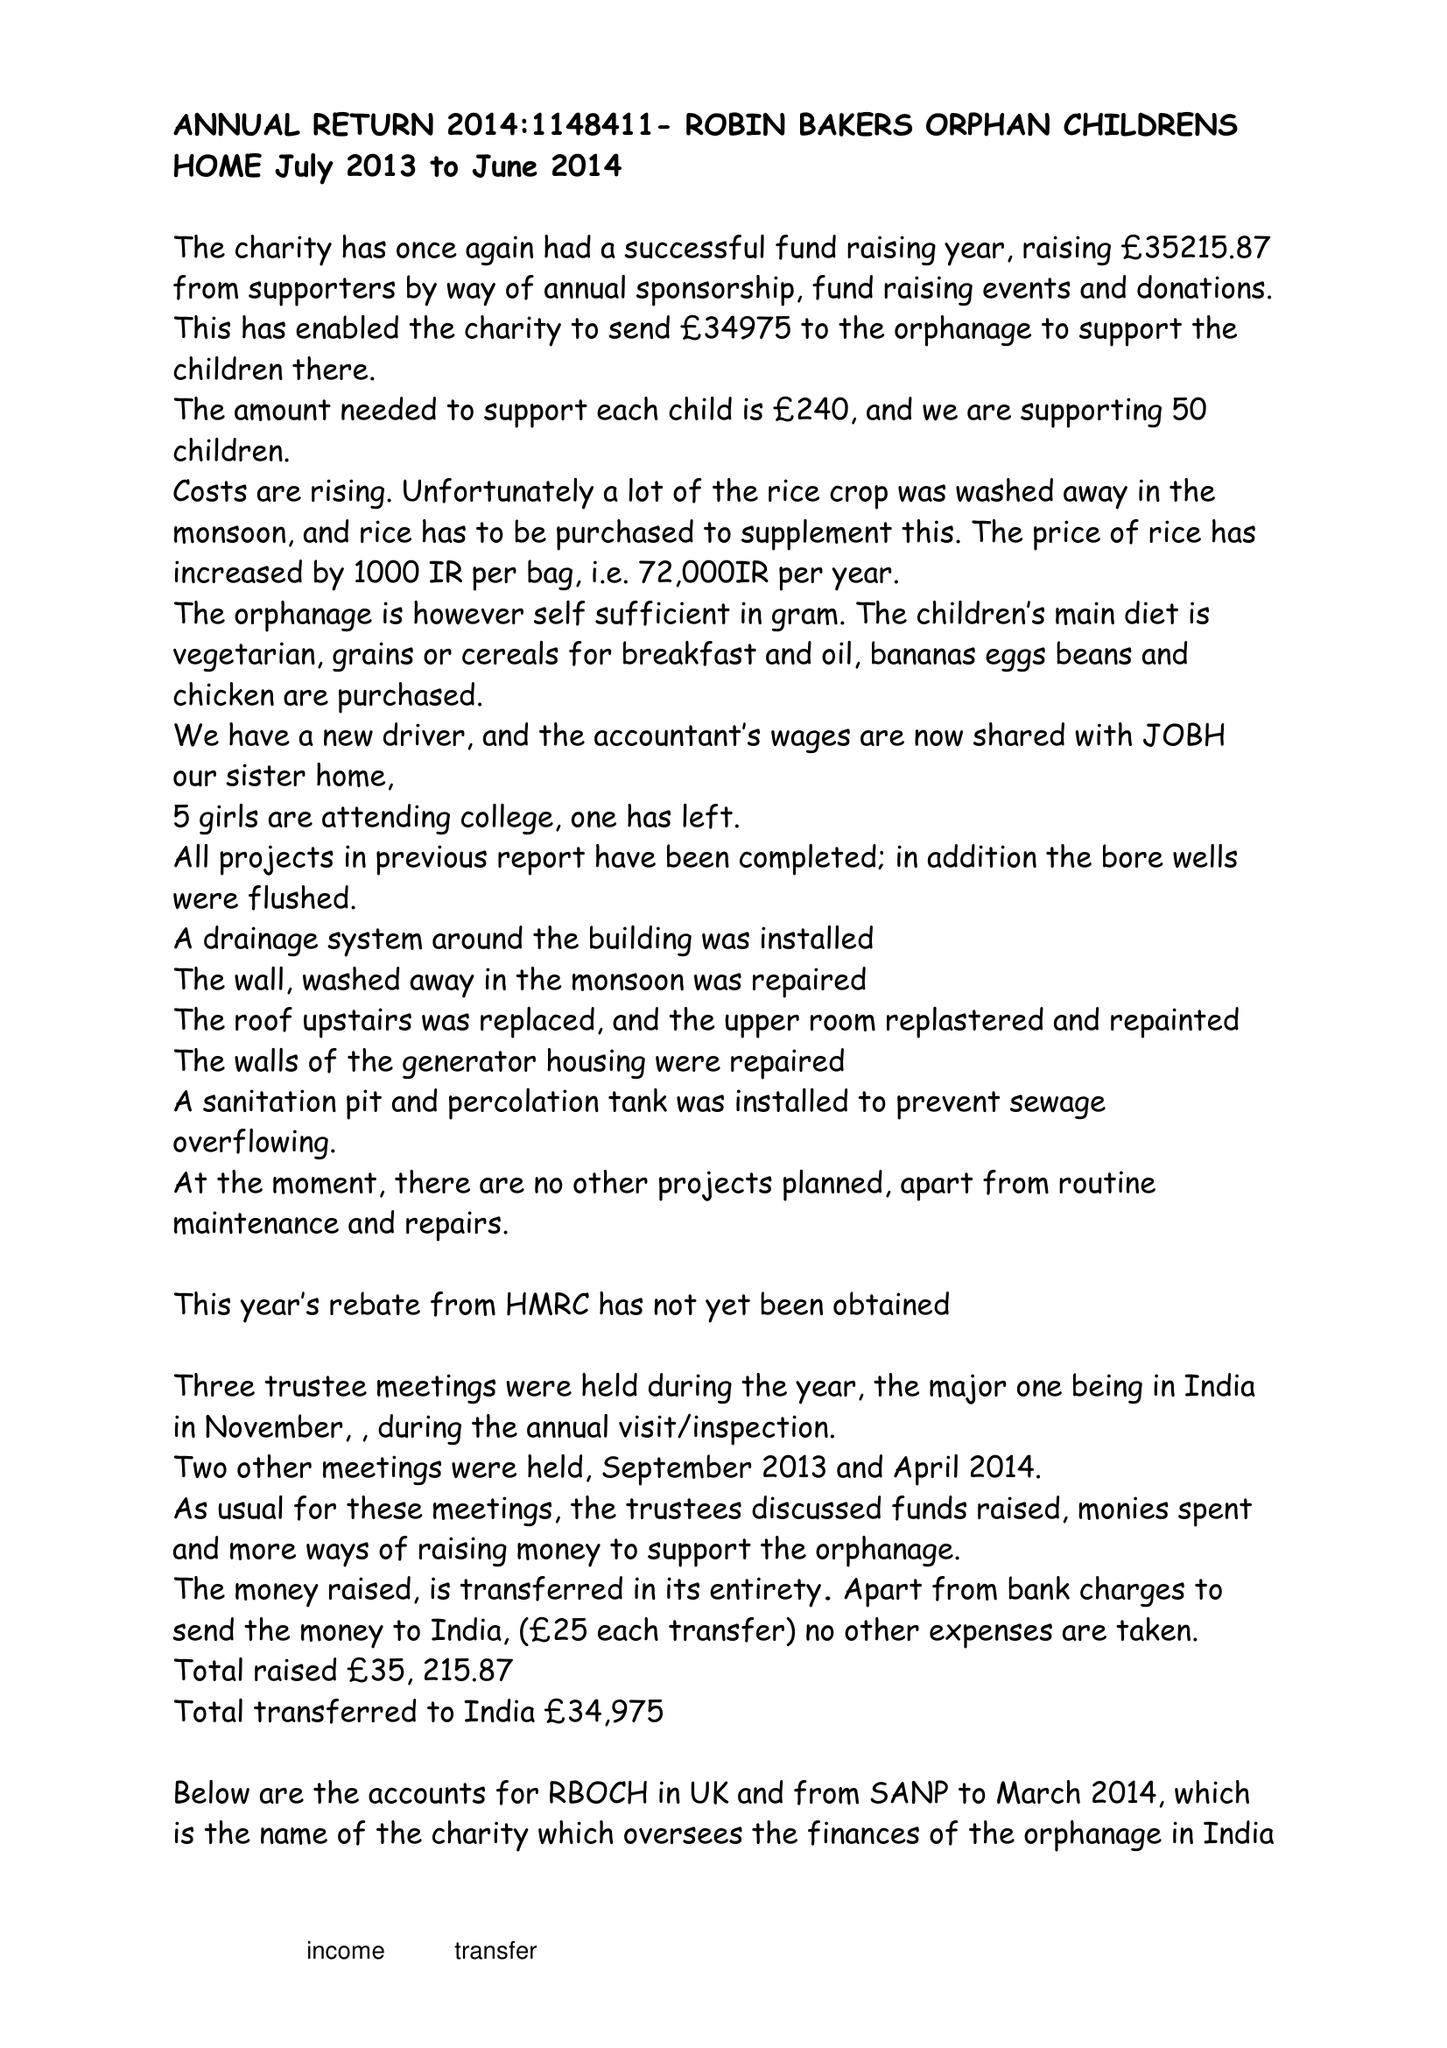What is the value for the charity_name?
Answer the question using a single word or phrase. Robin Bakers Orphan Childrens Home 